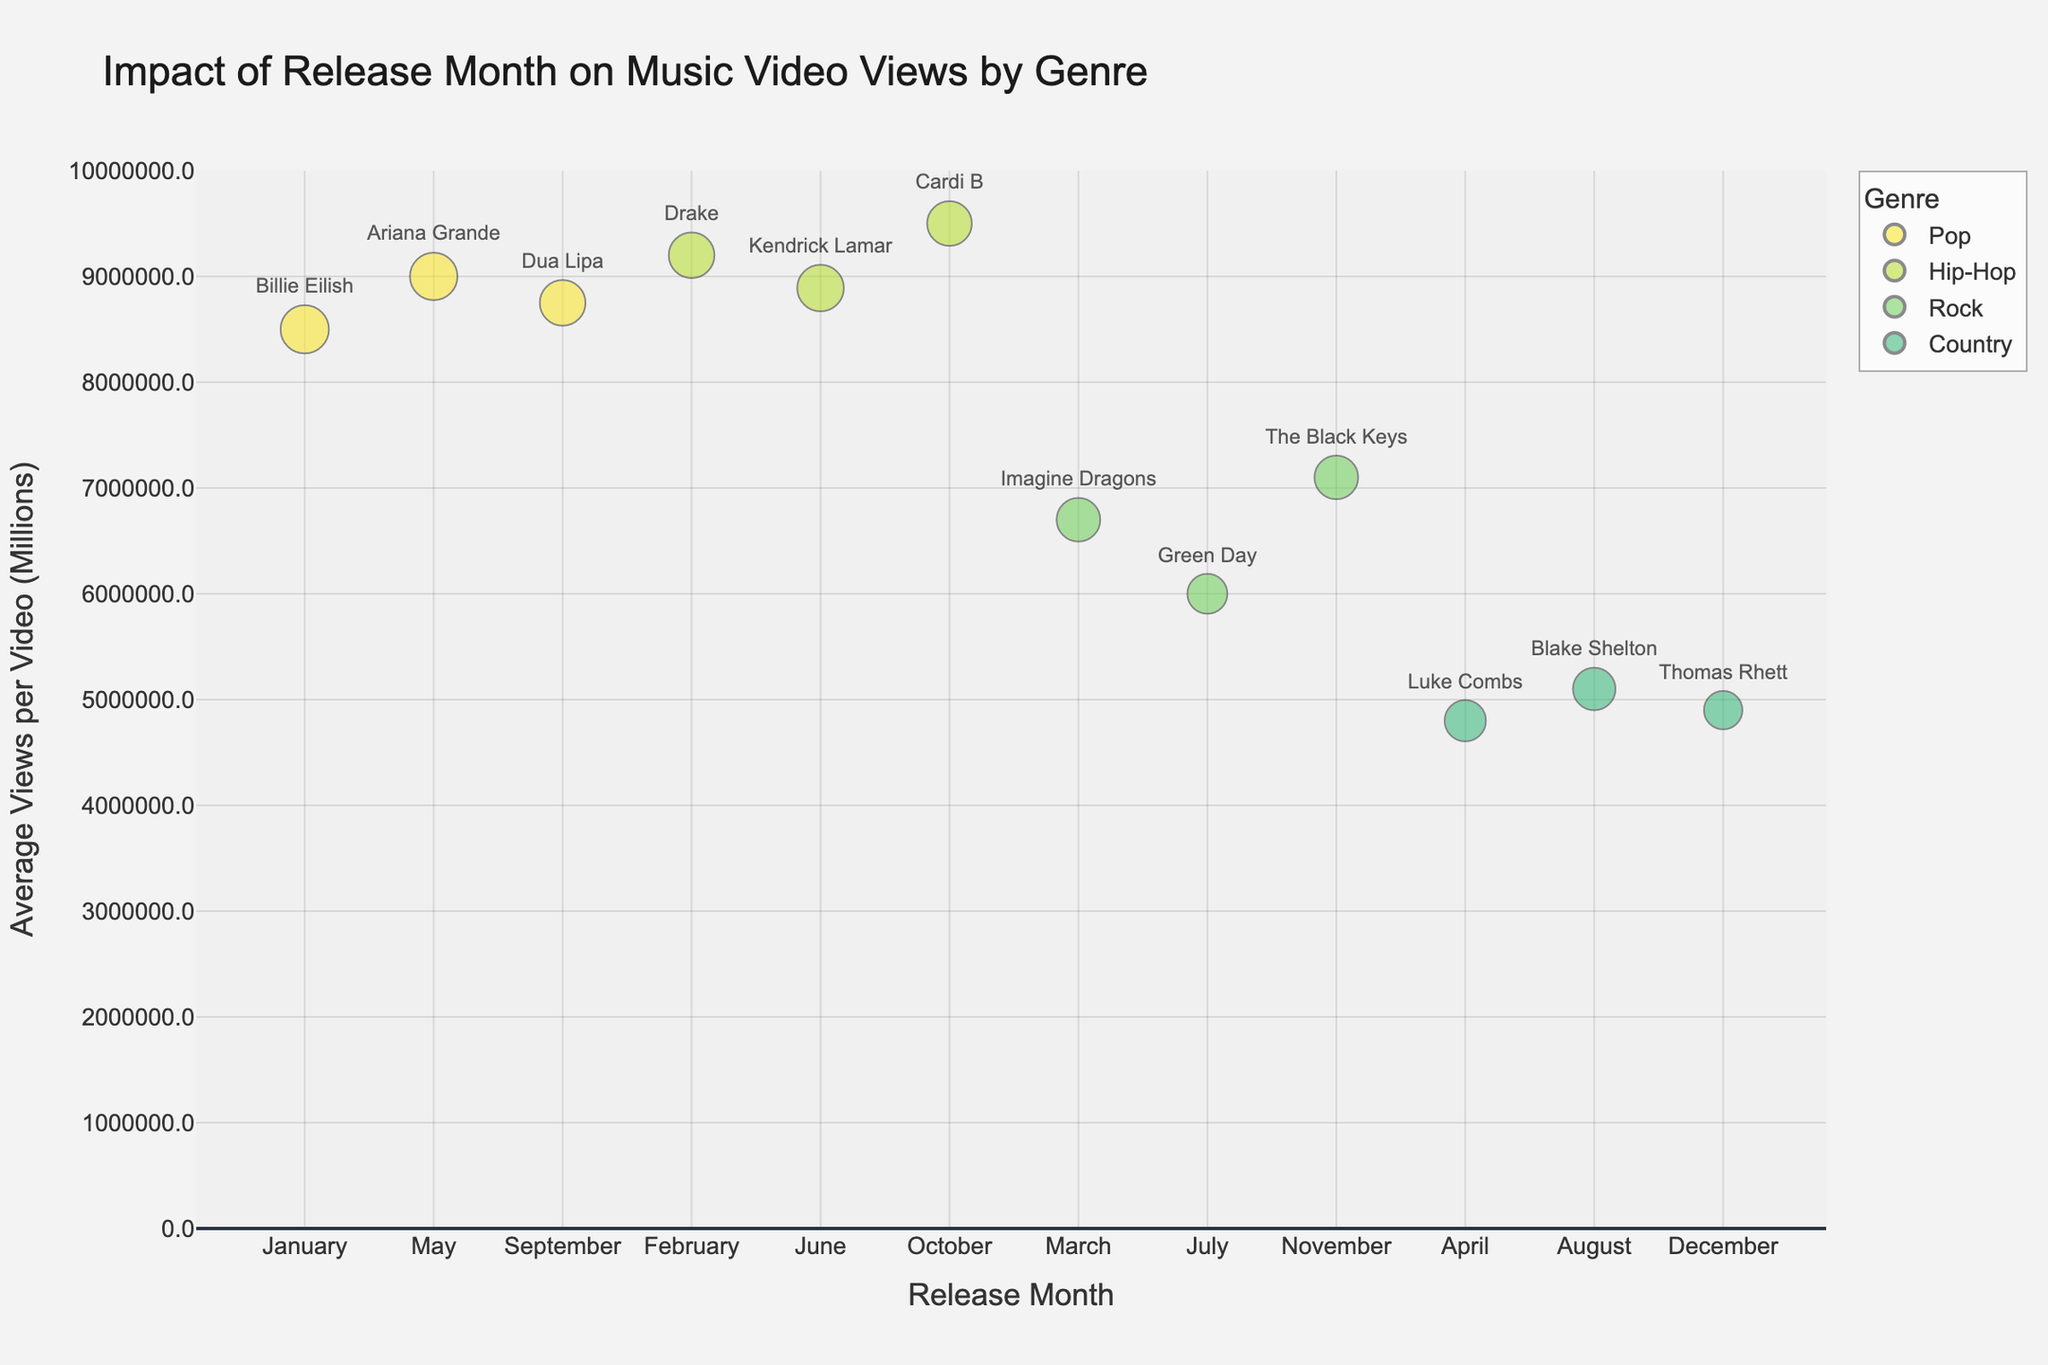What is the title of the bubble chart? The title is written at the top center of the chart, which summarizes the main idea of the visual representation.
Answer: Impact of Release Month on Music Video Views by Genre Which genre has the music video with the highest average views per video? Identify the highest data point on the y-axis (Average Views per Video) and see which genre it belongs to based on the color and legend.
Answer: Hip-Hop How many music videos does Cardi B have in October? Locate the October bubble for Hip-Hop (color as per legend), hover over it or check the text/hover details to find the exact number of videos.
Answer: 11 Which release month has the lowest average views for music videos? Look for the data point with the lowest y-value (Average Views per Video) and note the corresponding Release Month on the x-axis.
Answer: December What is the average engagement rate for Imagine Dragons in March? Find the March bubble for Rock (according to color and legend), hover over it or check the hover details to locate the average engagement rate.
Answer: 4.8 Which artist has the highest average views per video in the Hip-Hop genre? Compare the y-values for all bubbles colored as Hip-Hop and identify the corresponding artist with the highest y-value.
Answer: Cardi B How many videos does Green Day have, and what is their average views per video? Locate the July bubble for Rock (as per color and legend), hover over it to get the specific number of videos and average views.
Answer: 7, 6,000,000 During which month do Pop genre videos have the highest average views per video? Compare y-values of all bubbles colored for Pop across different months and identify the highest one.
Answer: February Which genre has the smallest bubble size, and which artist does it correspond to? Smallest bubbles can be identified visually and by comparing bubble sizes. Note the genre and artist from the smallest bubble.
Answer: Country, Thomas Rhett What is the difference in average views per video between Ariana Grande and Dua Lipa? Locate bubbles for Ariana Grande (May) and Dua Lipa (September). Note their y-values (average views per video) and calculate the difference.
Answer: 2,500,000 